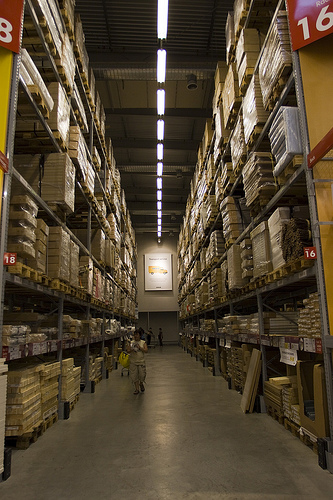<image>
Is there a pallets in front of the shelf? No. The pallets is not in front of the shelf. The spatial positioning shows a different relationship between these objects. 